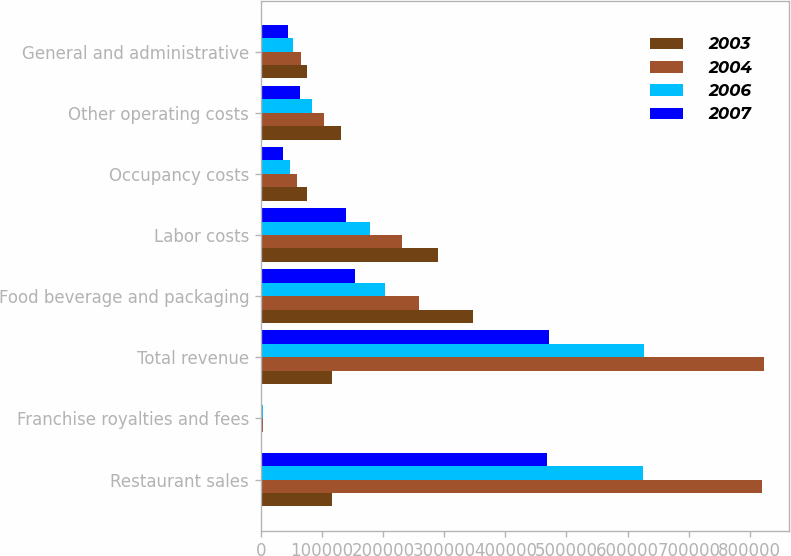Convert chart. <chart><loc_0><loc_0><loc_500><loc_500><stacked_bar_chart><ecel><fcel>Restaurant sales<fcel>Franchise royalties and fees<fcel>Total revenue<fcel>Food beverage and packaging<fcel>Labor costs<fcel>Occupancy costs<fcel>Other operating costs<fcel>General and administrative<nl><fcel>2003<fcel>117128<fcel>735<fcel>117128<fcel>346393<fcel>289417<fcel>75891<fcel>131512<fcel>75038<nl><fcel>2004<fcel>819787<fcel>3143<fcel>822930<fcel>257998<fcel>231134<fcel>58804<fcel>102745<fcel>65284<nl><fcel>2006<fcel>625077<fcel>2618<fcel>627695<fcel>202288<fcel>178721<fcel>47636<fcel>82976<fcel>51964<nl><fcel>2007<fcel>468579<fcel>2142<fcel>470721<fcel>154148<fcel>139494<fcel>36190<fcel>64274<fcel>44837<nl></chart> 